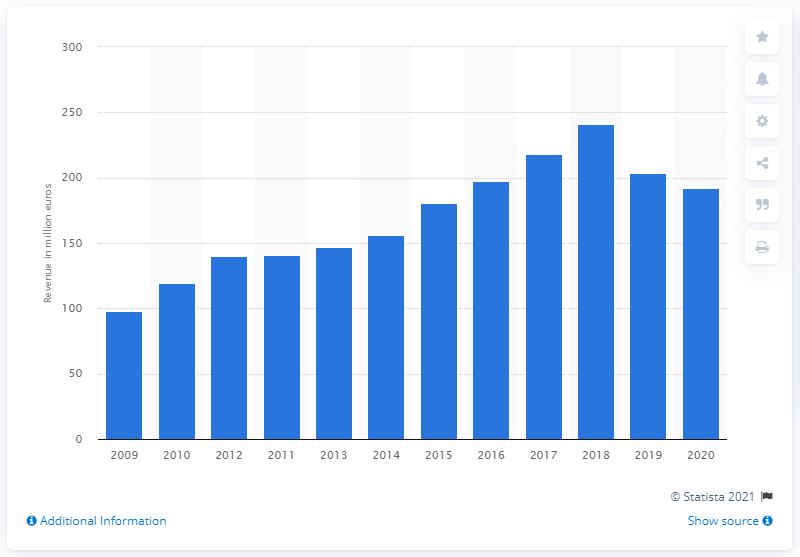Identify some key points in this picture. In 2020, Data Modul's global revenue was approximately 192.19 million dollars. 